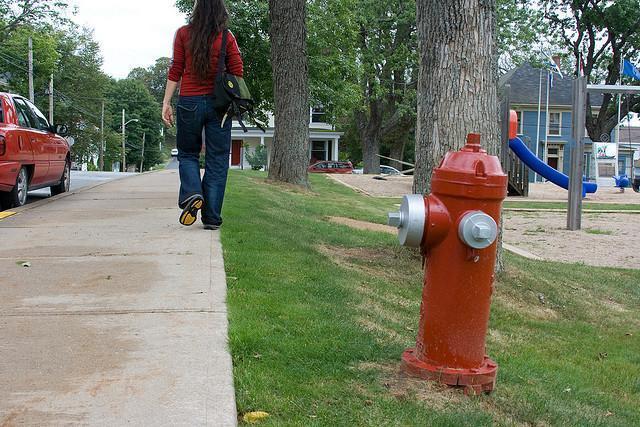How many kids playing in the playground?
Give a very brief answer. 0. How many people are there?
Give a very brief answer. 1. 